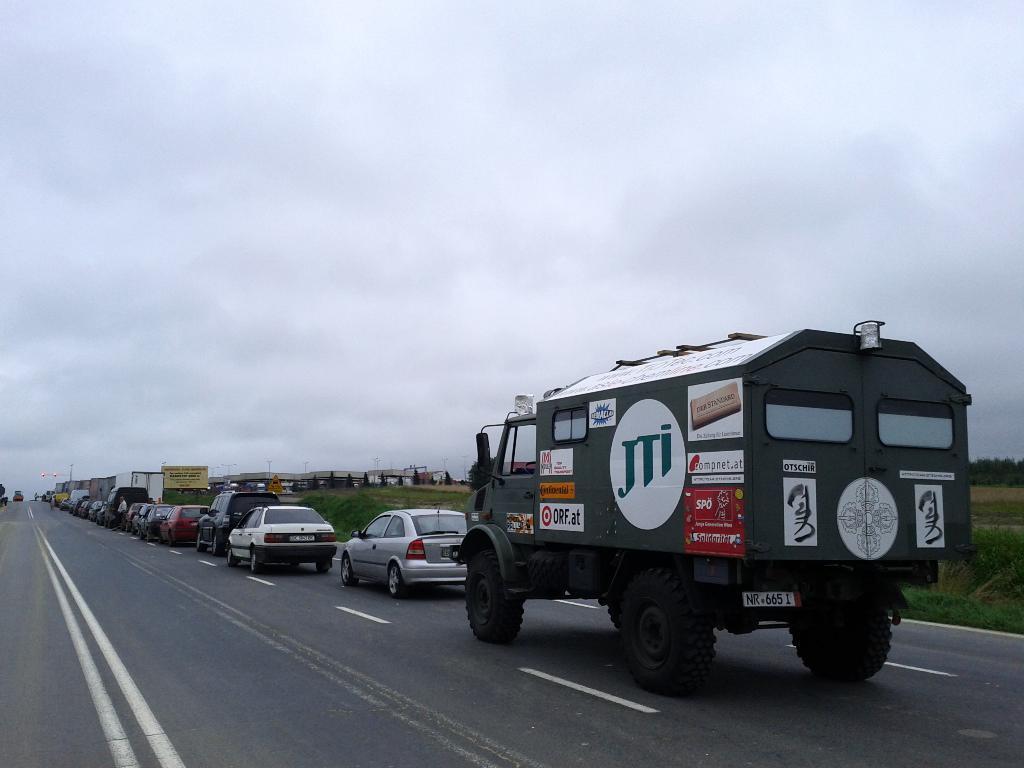Could you give a brief overview of what you see in this image? In the picture I can see vehicles on the road. In the background I can see the sky, trees, the grass, boards, street lights and some other objects. 